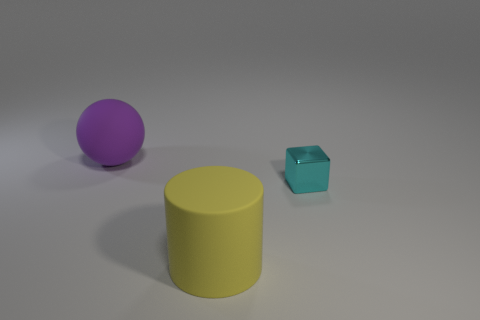Is the size of the matte object that is in front of the purple thing the same as the big purple sphere?
Ensure brevity in your answer.  Yes. Is there another yellow matte cylinder of the same size as the yellow cylinder?
Ensure brevity in your answer.  No. Is there a large rubber cube of the same color as the big cylinder?
Provide a short and direct response. No. What number of other objects are the same shape as the cyan metal thing?
Your answer should be very brief. 0. What is the shape of the rubber object right of the big purple sphere?
Provide a short and direct response. Cylinder. There is a cyan object; is its shape the same as the big rubber object that is in front of the cyan object?
Keep it short and to the point. No. What size is the thing that is behind the big yellow rubber thing and right of the sphere?
Offer a terse response. Small. There is a thing that is both left of the tiny metal object and behind the large cylinder; what is its color?
Provide a short and direct response. Purple. Is there anything else that is the same material as the cyan object?
Keep it short and to the point. No. Is the number of small metallic cubes behind the tiny cyan object less than the number of matte objects on the left side of the purple thing?
Your response must be concise. No. 